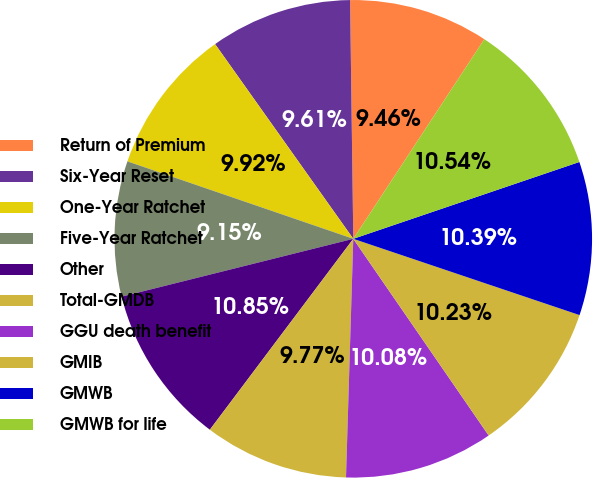<chart> <loc_0><loc_0><loc_500><loc_500><pie_chart><fcel>Return of Premium<fcel>Six-Year Reset<fcel>One-Year Ratchet<fcel>Five-Year Ratchet<fcel>Other<fcel>Total-GMDB<fcel>GGU death benefit<fcel>GMIB<fcel>GMWB<fcel>GMWB for life<nl><fcel>9.46%<fcel>9.61%<fcel>9.92%<fcel>9.15%<fcel>10.85%<fcel>9.77%<fcel>10.08%<fcel>10.23%<fcel>10.39%<fcel>10.54%<nl></chart> 